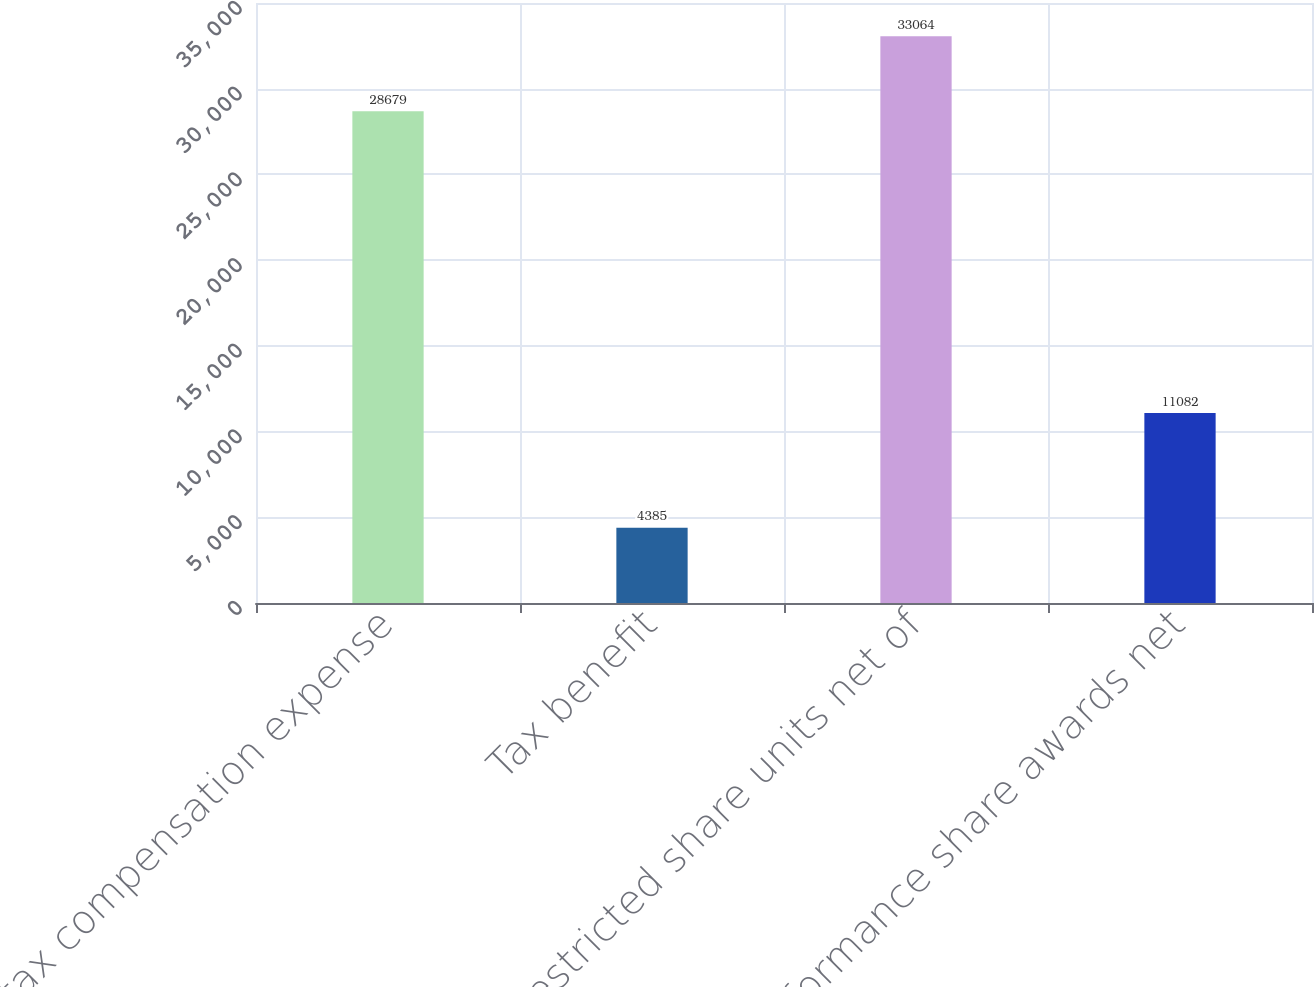<chart> <loc_0><loc_0><loc_500><loc_500><bar_chart><fcel>Pretax compensation expense<fcel>Tax benefit<fcel>Restricted share units net of<fcel>Performance share awards net<nl><fcel>28679<fcel>4385<fcel>33064<fcel>11082<nl></chart> 